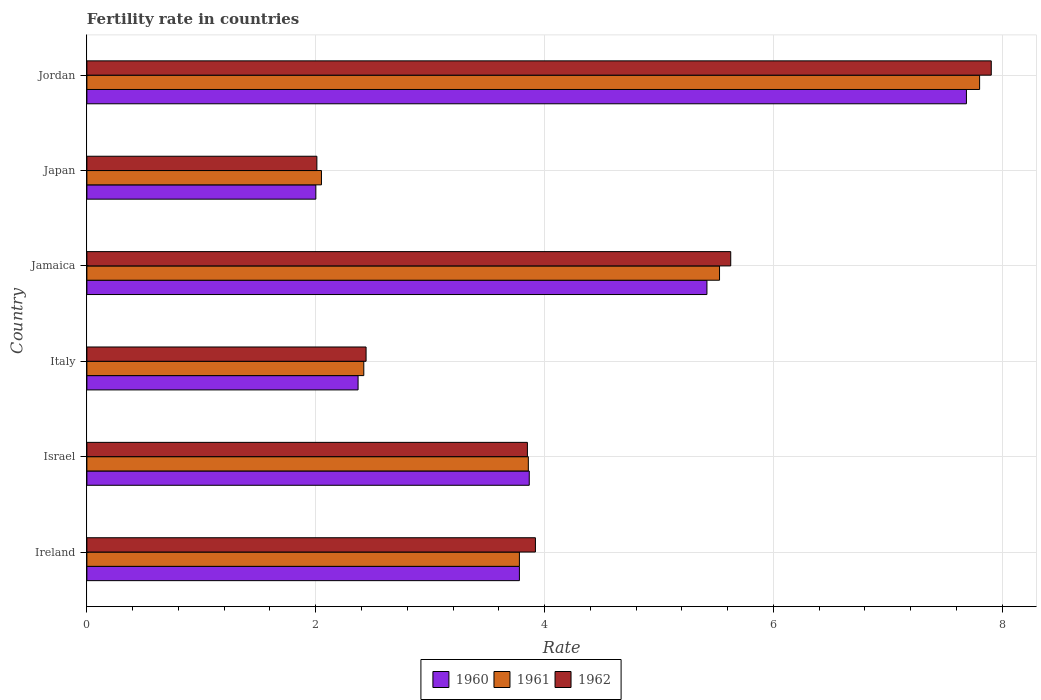How many groups of bars are there?
Provide a short and direct response. 6. What is the fertility rate in 1960 in Ireland?
Your answer should be very brief. 3.78. Across all countries, what is the maximum fertility rate in 1961?
Keep it short and to the point. 7.8. Across all countries, what is the minimum fertility rate in 1960?
Keep it short and to the point. 2. In which country was the fertility rate in 1961 maximum?
Your answer should be very brief. Jordan. What is the total fertility rate in 1960 in the graph?
Provide a short and direct response. 25.12. What is the difference between the fertility rate in 1960 in Jamaica and that in Jordan?
Provide a short and direct response. -2.27. What is the difference between the fertility rate in 1960 in Israel and the fertility rate in 1962 in Jordan?
Give a very brief answer. -4.04. What is the average fertility rate in 1960 per country?
Give a very brief answer. 4.19. What is the difference between the fertility rate in 1961 and fertility rate in 1960 in Ireland?
Your answer should be compact. 0. In how many countries, is the fertility rate in 1962 greater than 3.6 ?
Keep it short and to the point. 4. What is the ratio of the fertility rate in 1961 in Israel to that in Jordan?
Make the answer very short. 0.49. Is the fertility rate in 1961 in Ireland less than that in Japan?
Offer a terse response. No. What is the difference between the highest and the second highest fertility rate in 1960?
Offer a very short reply. 2.27. What is the difference between the highest and the lowest fertility rate in 1962?
Offer a very short reply. 5.89. In how many countries, is the fertility rate in 1961 greater than the average fertility rate in 1961 taken over all countries?
Your answer should be compact. 2. Is the sum of the fertility rate in 1961 in Israel and Italy greater than the maximum fertility rate in 1960 across all countries?
Provide a succinct answer. No. What is the difference between two consecutive major ticks on the X-axis?
Give a very brief answer. 2. Are the values on the major ticks of X-axis written in scientific E-notation?
Your response must be concise. No. Does the graph contain grids?
Your answer should be compact. Yes. What is the title of the graph?
Keep it short and to the point. Fertility rate in countries. What is the label or title of the X-axis?
Your answer should be very brief. Rate. What is the label or title of the Y-axis?
Provide a succinct answer. Country. What is the Rate in 1960 in Ireland?
Offer a very short reply. 3.78. What is the Rate of 1961 in Ireland?
Keep it short and to the point. 3.78. What is the Rate of 1962 in Ireland?
Your response must be concise. 3.92. What is the Rate of 1960 in Israel?
Offer a terse response. 3.87. What is the Rate in 1961 in Israel?
Your response must be concise. 3.86. What is the Rate of 1962 in Israel?
Provide a short and direct response. 3.85. What is the Rate of 1960 in Italy?
Make the answer very short. 2.37. What is the Rate of 1961 in Italy?
Provide a succinct answer. 2.42. What is the Rate in 1962 in Italy?
Make the answer very short. 2.44. What is the Rate of 1960 in Jamaica?
Offer a terse response. 5.42. What is the Rate in 1961 in Jamaica?
Give a very brief answer. 5.53. What is the Rate in 1962 in Jamaica?
Provide a short and direct response. 5.63. What is the Rate in 1960 in Japan?
Keep it short and to the point. 2. What is the Rate of 1961 in Japan?
Keep it short and to the point. 2.05. What is the Rate of 1962 in Japan?
Give a very brief answer. 2.01. What is the Rate of 1960 in Jordan?
Your response must be concise. 7.69. What is the Rate of 1961 in Jordan?
Your response must be concise. 7.8. What is the Rate of 1962 in Jordan?
Provide a succinct answer. 7.9. Across all countries, what is the maximum Rate in 1960?
Give a very brief answer. 7.69. Across all countries, what is the maximum Rate of 1961?
Your answer should be very brief. 7.8. Across all countries, what is the maximum Rate of 1962?
Give a very brief answer. 7.9. Across all countries, what is the minimum Rate in 1960?
Give a very brief answer. 2. Across all countries, what is the minimum Rate of 1961?
Offer a very short reply. 2.05. Across all countries, what is the minimum Rate in 1962?
Keep it short and to the point. 2.01. What is the total Rate in 1960 in the graph?
Your answer should be compact. 25.12. What is the total Rate in 1961 in the graph?
Provide a short and direct response. 25.44. What is the total Rate in 1962 in the graph?
Offer a terse response. 25.75. What is the difference between the Rate in 1960 in Ireland and that in Israel?
Offer a very short reply. -0.09. What is the difference between the Rate of 1961 in Ireland and that in Israel?
Provide a succinct answer. -0.08. What is the difference between the Rate in 1962 in Ireland and that in Israel?
Keep it short and to the point. 0.07. What is the difference between the Rate in 1960 in Ireland and that in Italy?
Offer a terse response. 1.41. What is the difference between the Rate of 1961 in Ireland and that in Italy?
Ensure brevity in your answer.  1.36. What is the difference between the Rate of 1962 in Ireland and that in Italy?
Your answer should be compact. 1.48. What is the difference between the Rate in 1960 in Ireland and that in Jamaica?
Ensure brevity in your answer.  -1.64. What is the difference between the Rate of 1961 in Ireland and that in Jamaica?
Ensure brevity in your answer.  -1.75. What is the difference between the Rate of 1962 in Ireland and that in Jamaica?
Offer a terse response. -1.71. What is the difference between the Rate in 1960 in Ireland and that in Japan?
Keep it short and to the point. 1.78. What is the difference between the Rate of 1961 in Ireland and that in Japan?
Provide a short and direct response. 1.73. What is the difference between the Rate of 1962 in Ireland and that in Japan?
Ensure brevity in your answer.  1.91. What is the difference between the Rate in 1960 in Ireland and that in Jordan?
Provide a short and direct response. -3.91. What is the difference between the Rate in 1961 in Ireland and that in Jordan?
Provide a succinct answer. -4.02. What is the difference between the Rate in 1962 in Ireland and that in Jordan?
Ensure brevity in your answer.  -3.98. What is the difference between the Rate of 1960 in Israel and that in Italy?
Give a very brief answer. 1.5. What is the difference between the Rate of 1961 in Israel and that in Italy?
Ensure brevity in your answer.  1.44. What is the difference between the Rate of 1962 in Israel and that in Italy?
Offer a very short reply. 1.41. What is the difference between the Rate of 1960 in Israel and that in Jamaica?
Offer a terse response. -1.55. What is the difference between the Rate in 1961 in Israel and that in Jamaica?
Offer a very short reply. -1.67. What is the difference between the Rate in 1962 in Israel and that in Jamaica?
Offer a terse response. -1.78. What is the difference between the Rate of 1960 in Israel and that in Japan?
Offer a very short reply. 1.86. What is the difference between the Rate of 1961 in Israel and that in Japan?
Offer a very short reply. 1.81. What is the difference between the Rate of 1962 in Israel and that in Japan?
Provide a succinct answer. 1.84. What is the difference between the Rate in 1960 in Israel and that in Jordan?
Offer a terse response. -3.82. What is the difference between the Rate in 1961 in Israel and that in Jordan?
Provide a succinct answer. -3.94. What is the difference between the Rate in 1962 in Israel and that in Jordan?
Keep it short and to the point. -4.05. What is the difference between the Rate of 1960 in Italy and that in Jamaica?
Ensure brevity in your answer.  -3.05. What is the difference between the Rate in 1961 in Italy and that in Jamaica?
Ensure brevity in your answer.  -3.11. What is the difference between the Rate of 1962 in Italy and that in Jamaica?
Keep it short and to the point. -3.19. What is the difference between the Rate in 1960 in Italy and that in Japan?
Provide a short and direct response. 0.37. What is the difference between the Rate of 1961 in Italy and that in Japan?
Provide a short and direct response. 0.37. What is the difference between the Rate of 1962 in Italy and that in Japan?
Your answer should be compact. 0.43. What is the difference between the Rate in 1960 in Italy and that in Jordan?
Your answer should be very brief. -5.32. What is the difference between the Rate in 1961 in Italy and that in Jordan?
Make the answer very short. -5.38. What is the difference between the Rate in 1962 in Italy and that in Jordan?
Offer a very short reply. -5.46. What is the difference between the Rate in 1960 in Jamaica and that in Japan?
Provide a succinct answer. 3.42. What is the difference between the Rate in 1961 in Jamaica and that in Japan?
Offer a very short reply. 3.48. What is the difference between the Rate in 1962 in Jamaica and that in Japan?
Give a very brief answer. 3.62. What is the difference between the Rate of 1960 in Jamaica and that in Jordan?
Provide a short and direct response. -2.27. What is the difference between the Rate of 1961 in Jamaica and that in Jordan?
Your response must be concise. -2.27. What is the difference between the Rate of 1962 in Jamaica and that in Jordan?
Offer a very short reply. -2.28. What is the difference between the Rate of 1960 in Japan and that in Jordan?
Your response must be concise. -5.69. What is the difference between the Rate in 1961 in Japan and that in Jordan?
Ensure brevity in your answer.  -5.75. What is the difference between the Rate in 1962 in Japan and that in Jordan?
Keep it short and to the point. -5.89. What is the difference between the Rate in 1960 in Ireland and the Rate in 1961 in Israel?
Give a very brief answer. -0.08. What is the difference between the Rate of 1960 in Ireland and the Rate of 1962 in Israel?
Ensure brevity in your answer.  -0.07. What is the difference between the Rate in 1961 in Ireland and the Rate in 1962 in Israel?
Your answer should be compact. -0.07. What is the difference between the Rate of 1960 in Ireland and the Rate of 1961 in Italy?
Your answer should be very brief. 1.36. What is the difference between the Rate in 1960 in Ireland and the Rate in 1962 in Italy?
Provide a short and direct response. 1.34. What is the difference between the Rate in 1961 in Ireland and the Rate in 1962 in Italy?
Provide a short and direct response. 1.34. What is the difference between the Rate in 1960 in Ireland and the Rate in 1961 in Jamaica?
Offer a terse response. -1.75. What is the difference between the Rate of 1960 in Ireland and the Rate of 1962 in Jamaica?
Make the answer very short. -1.85. What is the difference between the Rate of 1961 in Ireland and the Rate of 1962 in Jamaica?
Your answer should be compact. -1.85. What is the difference between the Rate in 1960 in Ireland and the Rate in 1961 in Japan?
Your answer should be very brief. 1.73. What is the difference between the Rate in 1960 in Ireland and the Rate in 1962 in Japan?
Make the answer very short. 1.77. What is the difference between the Rate of 1961 in Ireland and the Rate of 1962 in Japan?
Provide a succinct answer. 1.77. What is the difference between the Rate of 1960 in Ireland and the Rate of 1961 in Jordan?
Your answer should be very brief. -4.02. What is the difference between the Rate in 1960 in Ireland and the Rate in 1962 in Jordan?
Your response must be concise. -4.12. What is the difference between the Rate of 1961 in Ireland and the Rate of 1962 in Jordan?
Ensure brevity in your answer.  -4.12. What is the difference between the Rate of 1960 in Israel and the Rate of 1961 in Italy?
Offer a terse response. 1.45. What is the difference between the Rate of 1960 in Israel and the Rate of 1962 in Italy?
Your response must be concise. 1.43. What is the difference between the Rate of 1961 in Israel and the Rate of 1962 in Italy?
Your answer should be very brief. 1.42. What is the difference between the Rate of 1960 in Israel and the Rate of 1961 in Jamaica?
Your answer should be very brief. -1.66. What is the difference between the Rate of 1960 in Israel and the Rate of 1962 in Jamaica?
Your answer should be very brief. -1.76. What is the difference between the Rate of 1961 in Israel and the Rate of 1962 in Jamaica?
Keep it short and to the point. -1.77. What is the difference between the Rate in 1960 in Israel and the Rate in 1961 in Japan?
Your answer should be compact. 1.82. What is the difference between the Rate of 1960 in Israel and the Rate of 1962 in Japan?
Your response must be concise. 1.86. What is the difference between the Rate in 1961 in Israel and the Rate in 1962 in Japan?
Offer a terse response. 1.85. What is the difference between the Rate in 1960 in Israel and the Rate in 1961 in Jordan?
Provide a short and direct response. -3.94. What is the difference between the Rate in 1960 in Israel and the Rate in 1962 in Jordan?
Ensure brevity in your answer.  -4.04. What is the difference between the Rate in 1961 in Israel and the Rate in 1962 in Jordan?
Provide a succinct answer. -4.05. What is the difference between the Rate of 1960 in Italy and the Rate of 1961 in Jamaica?
Make the answer very short. -3.16. What is the difference between the Rate of 1960 in Italy and the Rate of 1962 in Jamaica?
Keep it short and to the point. -3.26. What is the difference between the Rate in 1961 in Italy and the Rate in 1962 in Jamaica?
Give a very brief answer. -3.21. What is the difference between the Rate of 1960 in Italy and the Rate of 1961 in Japan?
Offer a very short reply. 0.32. What is the difference between the Rate in 1960 in Italy and the Rate in 1962 in Japan?
Offer a very short reply. 0.36. What is the difference between the Rate of 1961 in Italy and the Rate of 1962 in Japan?
Offer a terse response. 0.41. What is the difference between the Rate of 1960 in Italy and the Rate of 1961 in Jordan?
Give a very brief answer. -5.43. What is the difference between the Rate of 1960 in Italy and the Rate of 1962 in Jordan?
Offer a very short reply. -5.53. What is the difference between the Rate in 1961 in Italy and the Rate in 1962 in Jordan?
Keep it short and to the point. -5.48. What is the difference between the Rate of 1960 in Jamaica and the Rate of 1961 in Japan?
Keep it short and to the point. 3.37. What is the difference between the Rate in 1960 in Jamaica and the Rate in 1962 in Japan?
Ensure brevity in your answer.  3.41. What is the difference between the Rate in 1961 in Jamaica and the Rate in 1962 in Japan?
Your answer should be very brief. 3.52. What is the difference between the Rate in 1960 in Jamaica and the Rate in 1961 in Jordan?
Give a very brief answer. -2.38. What is the difference between the Rate of 1960 in Jamaica and the Rate of 1962 in Jordan?
Your answer should be compact. -2.48. What is the difference between the Rate in 1961 in Jamaica and the Rate in 1962 in Jordan?
Make the answer very short. -2.38. What is the difference between the Rate in 1960 in Japan and the Rate in 1961 in Jordan?
Your answer should be very brief. -5.8. What is the difference between the Rate in 1960 in Japan and the Rate in 1962 in Jordan?
Provide a short and direct response. -5.9. What is the difference between the Rate of 1961 in Japan and the Rate of 1962 in Jordan?
Keep it short and to the point. -5.85. What is the average Rate in 1960 per country?
Provide a short and direct response. 4.19. What is the average Rate in 1961 per country?
Ensure brevity in your answer.  4.24. What is the average Rate in 1962 per country?
Your answer should be compact. 4.29. What is the difference between the Rate of 1960 and Rate of 1961 in Ireland?
Offer a terse response. 0. What is the difference between the Rate of 1960 and Rate of 1962 in Ireland?
Offer a very short reply. -0.14. What is the difference between the Rate in 1961 and Rate in 1962 in Ireland?
Provide a succinct answer. -0.14. What is the difference between the Rate of 1960 and Rate of 1961 in Israel?
Provide a succinct answer. 0.01. What is the difference between the Rate of 1960 and Rate of 1962 in Israel?
Your response must be concise. 0.02. What is the difference between the Rate of 1961 and Rate of 1962 in Israel?
Your response must be concise. 0.01. What is the difference between the Rate of 1960 and Rate of 1961 in Italy?
Give a very brief answer. -0.05. What is the difference between the Rate in 1960 and Rate in 1962 in Italy?
Offer a terse response. -0.07. What is the difference between the Rate of 1961 and Rate of 1962 in Italy?
Provide a short and direct response. -0.02. What is the difference between the Rate of 1960 and Rate of 1961 in Jamaica?
Your response must be concise. -0.11. What is the difference between the Rate in 1960 and Rate in 1962 in Jamaica?
Make the answer very short. -0.21. What is the difference between the Rate of 1961 and Rate of 1962 in Jamaica?
Provide a short and direct response. -0.1. What is the difference between the Rate in 1960 and Rate in 1961 in Japan?
Your answer should be compact. -0.05. What is the difference between the Rate of 1960 and Rate of 1962 in Japan?
Your answer should be very brief. -0.01. What is the difference between the Rate in 1960 and Rate in 1961 in Jordan?
Your answer should be compact. -0.12. What is the difference between the Rate of 1960 and Rate of 1962 in Jordan?
Your answer should be very brief. -0.22. What is the difference between the Rate in 1961 and Rate in 1962 in Jordan?
Keep it short and to the point. -0.1. What is the ratio of the Rate of 1960 in Ireland to that in Israel?
Provide a short and direct response. 0.98. What is the ratio of the Rate in 1961 in Ireland to that in Israel?
Offer a terse response. 0.98. What is the ratio of the Rate of 1962 in Ireland to that in Israel?
Make the answer very short. 1.02. What is the ratio of the Rate of 1960 in Ireland to that in Italy?
Make the answer very short. 1.59. What is the ratio of the Rate in 1961 in Ireland to that in Italy?
Your answer should be very brief. 1.56. What is the ratio of the Rate of 1962 in Ireland to that in Italy?
Your answer should be compact. 1.61. What is the ratio of the Rate in 1960 in Ireland to that in Jamaica?
Make the answer very short. 0.7. What is the ratio of the Rate in 1961 in Ireland to that in Jamaica?
Give a very brief answer. 0.68. What is the ratio of the Rate of 1962 in Ireland to that in Jamaica?
Offer a terse response. 0.7. What is the ratio of the Rate of 1960 in Ireland to that in Japan?
Your answer should be very brief. 1.89. What is the ratio of the Rate of 1961 in Ireland to that in Japan?
Your response must be concise. 1.84. What is the ratio of the Rate of 1962 in Ireland to that in Japan?
Offer a terse response. 1.95. What is the ratio of the Rate in 1960 in Ireland to that in Jordan?
Provide a succinct answer. 0.49. What is the ratio of the Rate of 1961 in Ireland to that in Jordan?
Give a very brief answer. 0.48. What is the ratio of the Rate of 1962 in Ireland to that in Jordan?
Make the answer very short. 0.5. What is the ratio of the Rate of 1960 in Israel to that in Italy?
Offer a terse response. 1.63. What is the ratio of the Rate of 1961 in Israel to that in Italy?
Your response must be concise. 1.59. What is the ratio of the Rate in 1962 in Israel to that in Italy?
Your answer should be compact. 1.58. What is the ratio of the Rate of 1960 in Israel to that in Jamaica?
Ensure brevity in your answer.  0.71. What is the ratio of the Rate of 1961 in Israel to that in Jamaica?
Offer a very short reply. 0.7. What is the ratio of the Rate in 1962 in Israel to that in Jamaica?
Give a very brief answer. 0.68. What is the ratio of the Rate in 1960 in Israel to that in Japan?
Offer a very short reply. 1.93. What is the ratio of the Rate in 1961 in Israel to that in Japan?
Your response must be concise. 1.88. What is the ratio of the Rate of 1962 in Israel to that in Japan?
Your answer should be very brief. 1.92. What is the ratio of the Rate of 1960 in Israel to that in Jordan?
Make the answer very short. 0.5. What is the ratio of the Rate in 1961 in Israel to that in Jordan?
Offer a terse response. 0.49. What is the ratio of the Rate of 1962 in Israel to that in Jordan?
Offer a terse response. 0.49. What is the ratio of the Rate in 1960 in Italy to that in Jamaica?
Your response must be concise. 0.44. What is the ratio of the Rate in 1961 in Italy to that in Jamaica?
Your answer should be very brief. 0.44. What is the ratio of the Rate of 1962 in Italy to that in Jamaica?
Ensure brevity in your answer.  0.43. What is the ratio of the Rate in 1960 in Italy to that in Japan?
Your response must be concise. 1.18. What is the ratio of the Rate of 1961 in Italy to that in Japan?
Provide a short and direct response. 1.18. What is the ratio of the Rate in 1962 in Italy to that in Japan?
Provide a succinct answer. 1.21. What is the ratio of the Rate in 1960 in Italy to that in Jordan?
Ensure brevity in your answer.  0.31. What is the ratio of the Rate in 1961 in Italy to that in Jordan?
Give a very brief answer. 0.31. What is the ratio of the Rate of 1962 in Italy to that in Jordan?
Your response must be concise. 0.31. What is the ratio of the Rate in 1960 in Jamaica to that in Japan?
Your answer should be compact. 2.71. What is the ratio of the Rate in 1961 in Jamaica to that in Japan?
Your response must be concise. 2.7. What is the ratio of the Rate in 1962 in Jamaica to that in Japan?
Offer a very short reply. 2.8. What is the ratio of the Rate of 1960 in Jamaica to that in Jordan?
Your answer should be compact. 0.7. What is the ratio of the Rate of 1961 in Jamaica to that in Jordan?
Your answer should be very brief. 0.71. What is the ratio of the Rate of 1962 in Jamaica to that in Jordan?
Your answer should be compact. 0.71. What is the ratio of the Rate in 1960 in Japan to that in Jordan?
Give a very brief answer. 0.26. What is the ratio of the Rate in 1961 in Japan to that in Jordan?
Ensure brevity in your answer.  0.26. What is the ratio of the Rate in 1962 in Japan to that in Jordan?
Provide a short and direct response. 0.25. What is the difference between the highest and the second highest Rate of 1960?
Ensure brevity in your answer.  2.27. What is the difference between the highest and the second highest Rate of 1961?
Offer a very short reply. 2.27. What is the difference between the highest and the second highest Rate of 1962?
Provide a short and direct response. 2.28. What is the difference between the highest and the lowest Rate in 1960?
Your answer should be very brief. 5.69. What is the difference between the highest and the lowest Rate of 1961?
Ensure brevity in your answer.  5.75. What is the difference between the highest and the lowest Rate of 1962?
Your response must be concise. 5.89. 